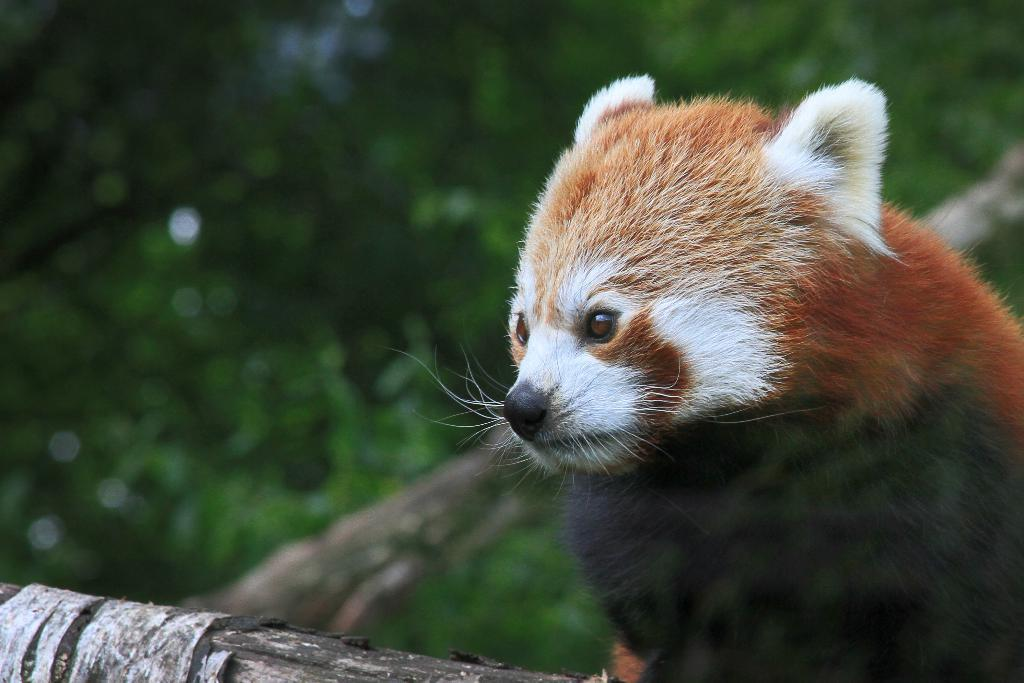Where was the picture taken? The picture was clicked outside. What animal can be seen on the right side of the image? There is a red panda on the right side of the image. What can be seen on the branches of trees in the image? There are branches of trees visible in the image. What color are the leaves in the background of the image? Green leaves are present in the background of the image. How many people are involved in the fight depicted in the image? There is no fight depicted in the image; it features a red panda and natural elements. 